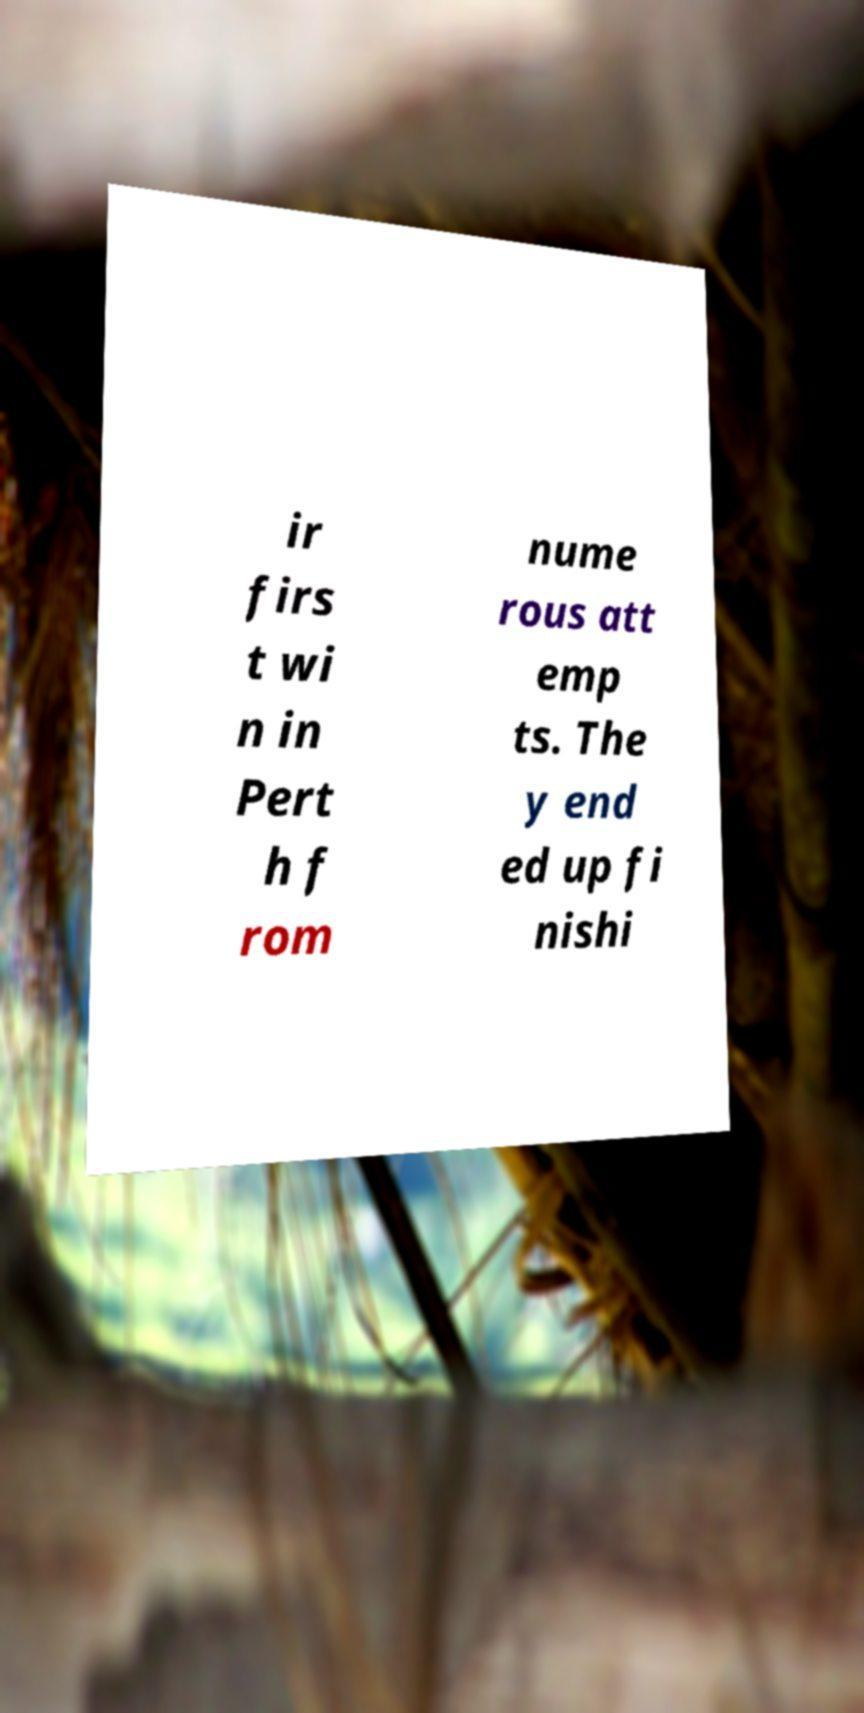What messages or text are displayed in this image? I need them in a readable, typed format. ir firs t wi n in Pert h f rom nume rous att emp ts. The y end ed up fi nishi 